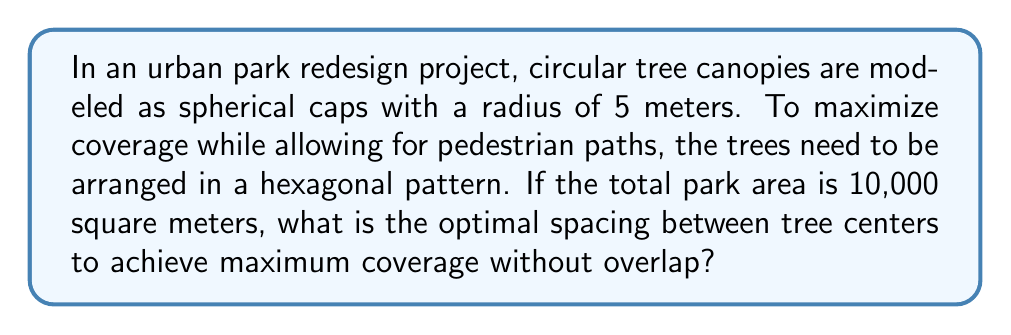What is the answer to this math problem? Let's approach this step-by-step:

1) In a hexagonal arrangement, each tree is surrounded by six others, forming equilateral triangles.

2) The area of an equilateral triangle with side length $s$ is:

   $$A = \frac{\sqrt{3}}{4}s^2$$

3) Each tree's circular projection covers an area of:

   $$A_{circle} = \pi r^2 = \pi(5^2) = 25\pi \approx 78.54 \text{ m}^2$$

4) In a perfect hexagonal packing, the ratio of circle area to total area is:

   $$\text{Packing density} = \frac{\pi}{2\sqrt{3}} \approx 0.9069$$

5) The total number of trees that can fit in the park:

   $$n = \frac{10000 \text{ m}^2}{78.54 \text{ m}^2} \times 0.9069 \approx 115.47$$

   Rounding down, we can fit 115 trees.

6) The area per tree in the hexagonal arrangement:

   $$A_{per\_tree} = \frac{10000 \text{ m}^2}{115} \approx 86.96 \text{ m}^2$$

7) This area corresponds to six equilateral triangles. So, the area of one triangle is:

   $$A_{triangle} = \frac{86.96 \text{ m}^2}{6} \approx 14.49 \text{ m}^2$$

8) Using the formula from step 2, we can find the side length $s$:

   $$14.49 = \frac{\sqrt{3}}{4}s^2$$
   $$s^2 = \frac{14.49 \times 4}{\sqrt{3}} \approx 33.46$$
   $$s = \sqrt{33.46} \approx 5.78 \text{ m}$$

Therefore, the optimal spacing between tree centers is approximately 5.78 meters.
Answer: 5.78 meters 